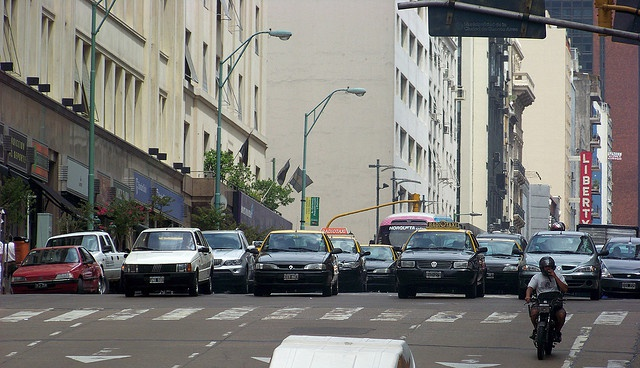Describe the objects in this image and their specific colors. I can see car in gray, black, and darkgray tones, car in gray, black, white, and darkgray tones, car in gray, black, and darkgray tones, car in gray, black, and darkgray tones, and car in gray, black, maroon, and brown tones in this image. 